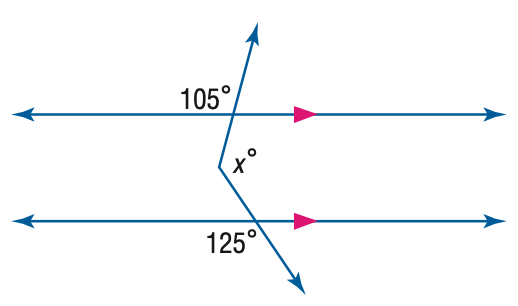Answer the mathemtical geometry problem and directly provide the correct option letter.
Question: Find x. (Hint: Draw an auxiliary line).
Choices: A: 105 B: 120 C: 125 D: 130 D 